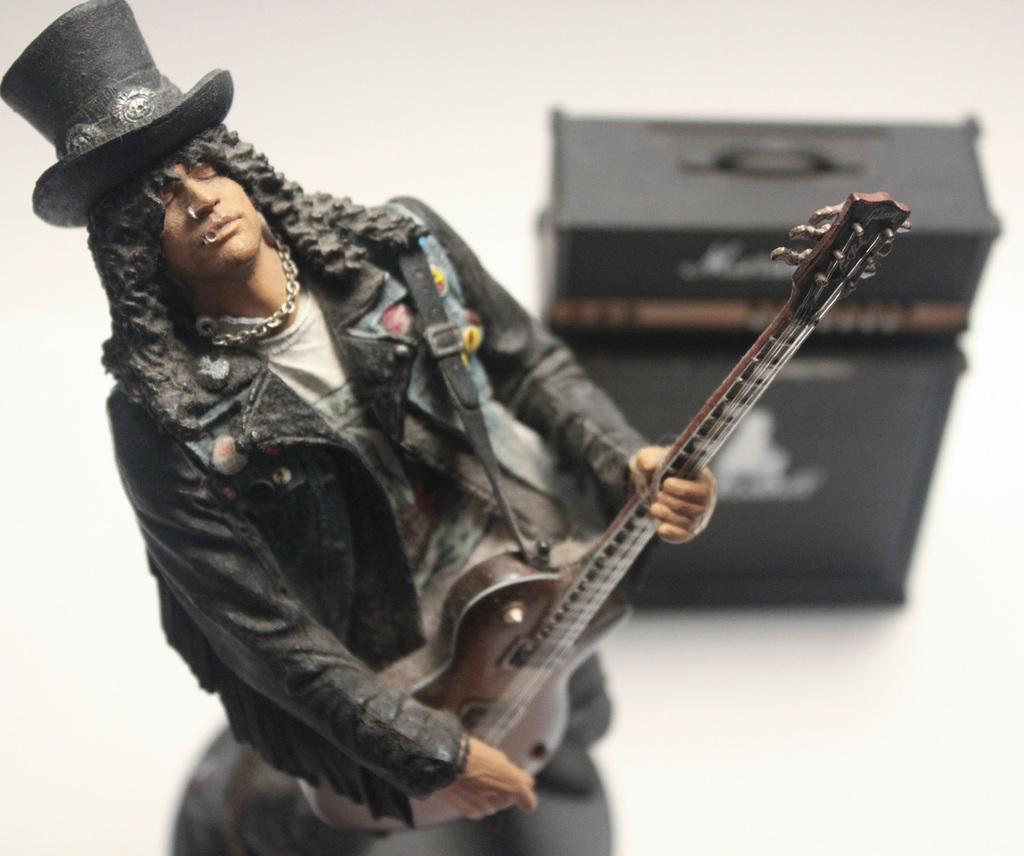Could you give a brief overview of what you see in this image? In the image we can see there is a man who is standing and holding guitar in his hand and it's a statue of a person. 